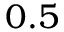Convert formula to latex. <formula><loc_0><loc_0><loc_500><loc_500>0 . 5</formula> 